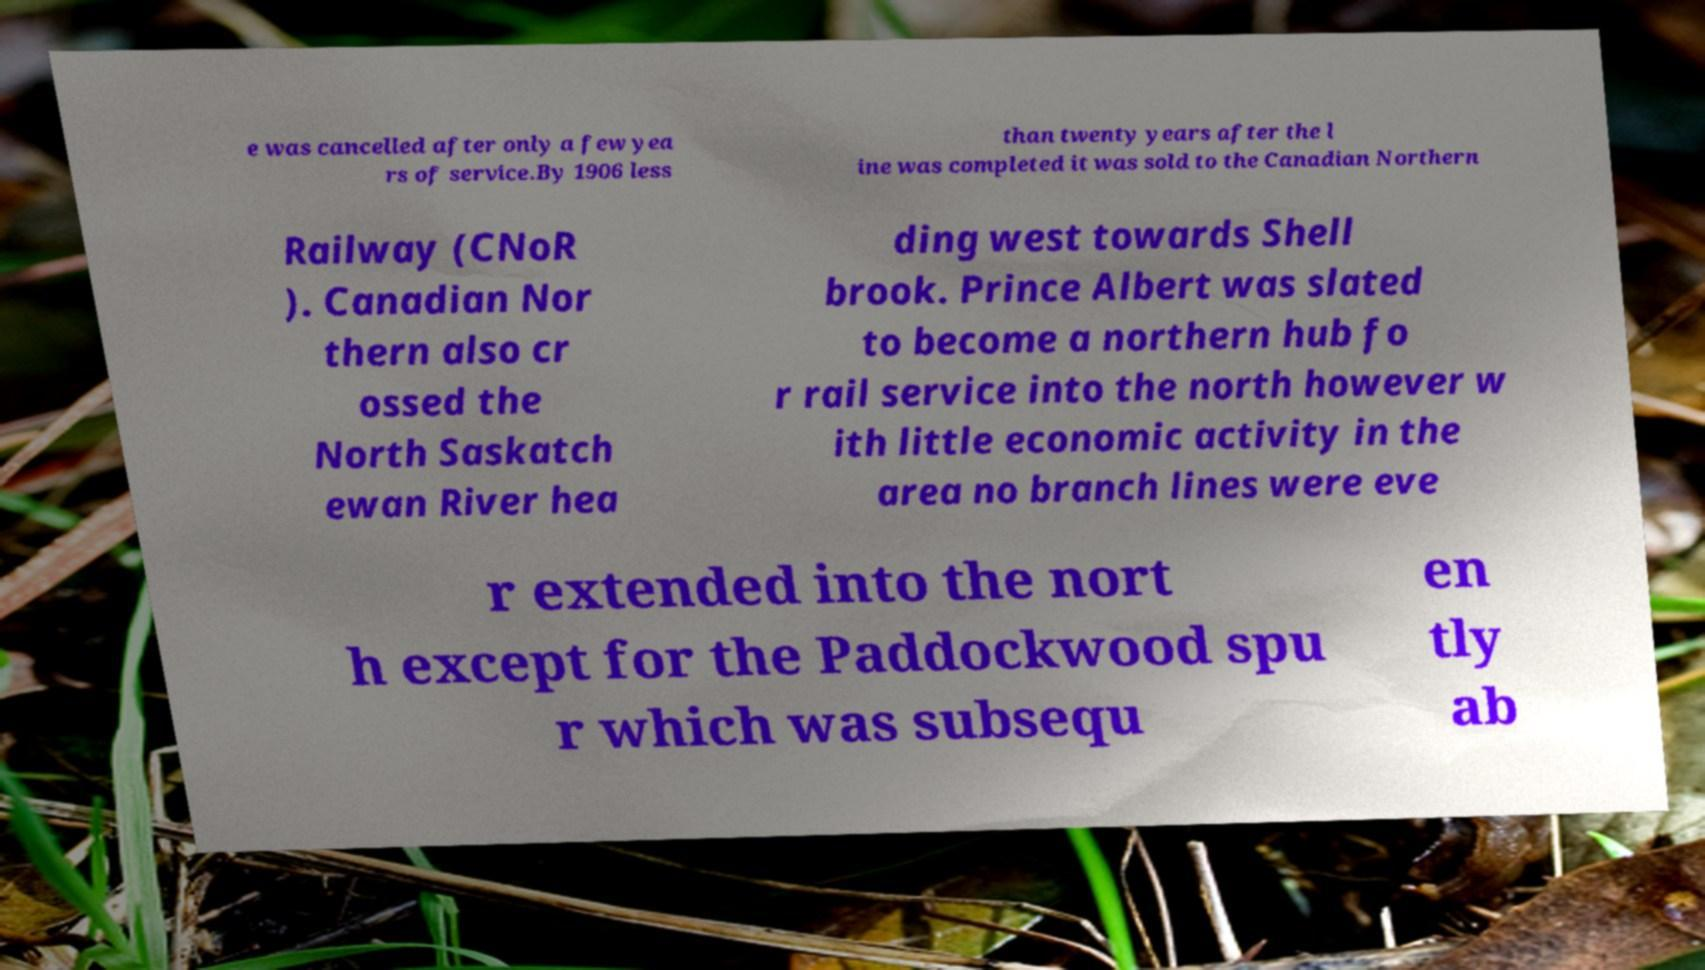I need the written content from this picture converted into text. Can you do that? e was cancelled after only a few yea rs of service.By 1906 less than twenty years after the l ine was completed it was sold to the Canadian Northern Railway (CNoR ). Canadian Nor thern also cr ossed the North Saskatch ewan River hea ding west towards Shell brook. Prince Albert was slated to become a northern hub fo r rail service into the north however w ith little economic activity in the area no branch lines were eve r extended into the nort h except for the Paddockwood spu r which was subsequ en tly ab 